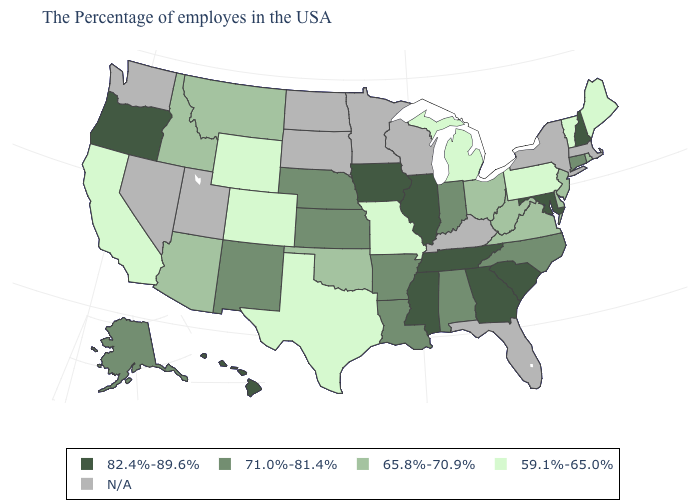What is the value of South Dakota?
Quick response, please. N/A. What is the value of North Carolina?
Write a very short answer. 71.0%-81.4%. Among the states that border Minnesota , which have the lowest value?
Give a very brief answer. Iowa. What is the lowest value in the USA?
Short answer required. 59.1%-65.0%. Does the map have missing data?
Concise answer only. Yes. Does Kansas have the highest value in the USA?
Write a very short answer. No. Among the states that border Montana , does Wyoming have the lowest value?
Be succinct. Yes. Does the map have missing data?
Quick response, please. Yes. Name the states that have a value in the range 65.8%-70.9%?
Write a very short answer. Rhode Island, New Jersey, Delaware, Virginia, West Virginia, Ohio, Oklahoma, Montana, Arizona, Idaho. Does New Hampshire have the highest value in the USA?
Quick response, please. Yes. Name the states that have a value in the range 59.1%-65.0%?
Be succinct. Maine, Vermont, Pennsylvania, Michigan, Missouri, Texas, Wyoming, Colorado, California. Does South Carolina have the lowest value in the USA?
Short answer required. No. What is the highest value in the USA?
Concise answer only. 82.4%-89.6%. What is the lowest value in the South?
Be succinct. 59.1%-65.0%. Which states have the lowest value in the South?
Short answer required. Texas. 